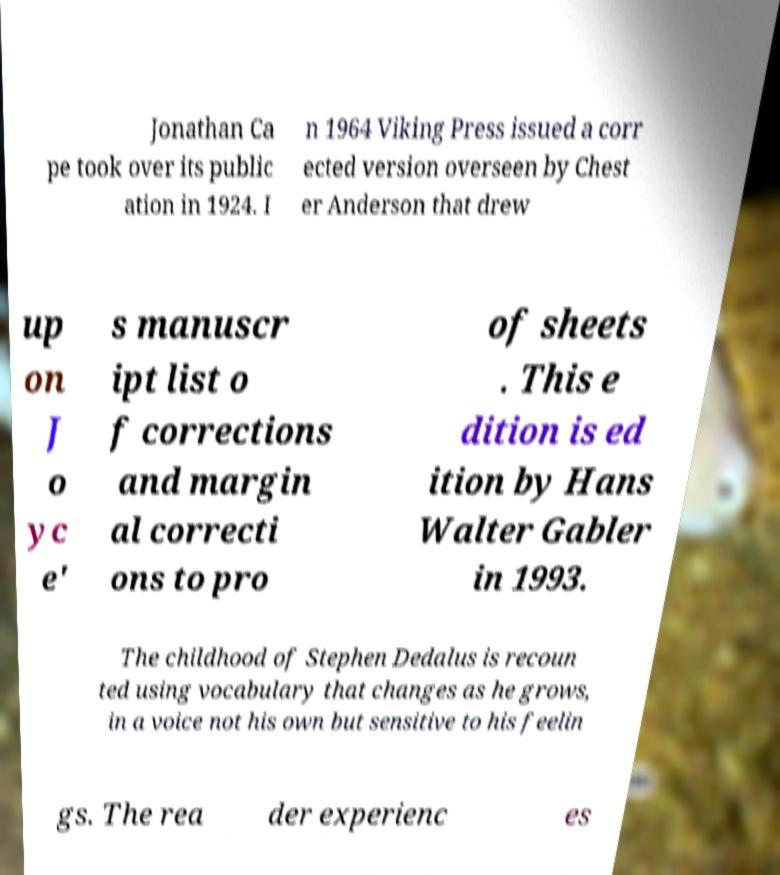For documentation purposes, I need the text within this image transcribed. Could you provide that? Jonathan Ca pe took over its public ation in 1924. I n 1964 Viking Press issued a corr ected version overseen by Chest er Anderson that drew up on J o yc e' s manuscr ipt list o f corrections and margin al correcti ons to pro of sheets . This e dition is ed ition by Hans Walter Gabler in 1993. The childhood of Stephen Dedalus is recoun ted using vocabulary that changes as he grows, in a voice not his own but sensitive to his feelin gs. The rea der experienc es 